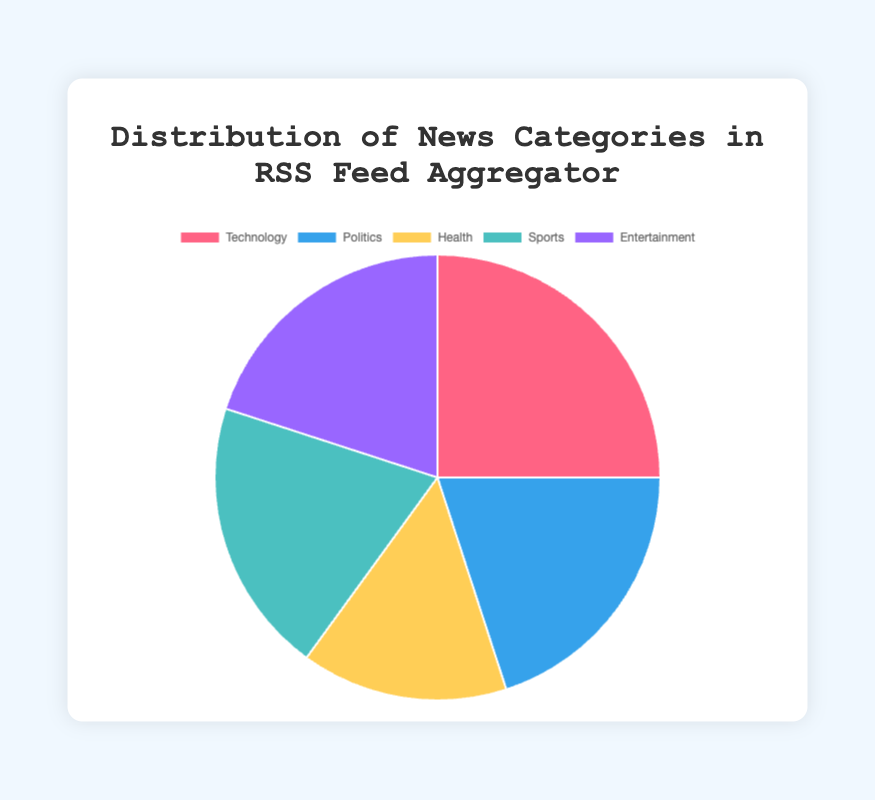What's the largest category in the RSS feed? To find this information, identify the category with the highest percentage on the pie chart. Here, Technology has the highest percentage at 25%.
Answer: Technology What's the combined percentage for Politics and Entertainment? Add the percentages of the Politics and Entertainment categories: Politics (20%) + Entertainment (20%) = 40%.
Answer: 40% Which category has the smallest percentage share? Compare all category percentages and identify the smallest. Health has the smallest share at 15%.
Answer: Health How do the percentage shares of Sports and Entertainment compare? Compare the percentage of Sports (20%) and Entertainment (20%). They are equal.
Answer: Equal What is the visual color representation of the Technology category in the chart? Identify the color used in the pie chart for the Technology slice. It is represented by red.
Answer: Red If you combine the percentages of Health and Technology, what is their total? Add the percentages of Health (15%) and Technology (25%): 15% + 25% = 40%.
Answer: 40% What's the difference in percentage between Technology and Health? Subtract the Health percentage (15%) from the Technology percentage (25%): 25% - 15% = 10%.
Answer: 10% What is the average percentage share of Politics, Sports, and Entertainment? Calculate the sum of the percentages for Politics (20%), Sports (20%), and Entertainment (20%) and divide by 3: (20% + 20% + 20%) / 3 = 60% / 3 = 20%.
Answer: 20% Which three categories combined make up 65% of the total distribution? Identify categories whose combined percentage equals 65%. Adding Technology (25%) + Politics (20%) + Health (15%) results in 60%, but adding Health (15%) + Sports (20%) + Entertainment (20%) results in 55%, then adding Technology (25%) + Health (15%) + Sports (20%) results in 60%. The only combination that fits is Technology (25%) + Politics (20%) + Entertainment (20%) equalling 65%.
Answer: Technology, Politics, Entertainment 